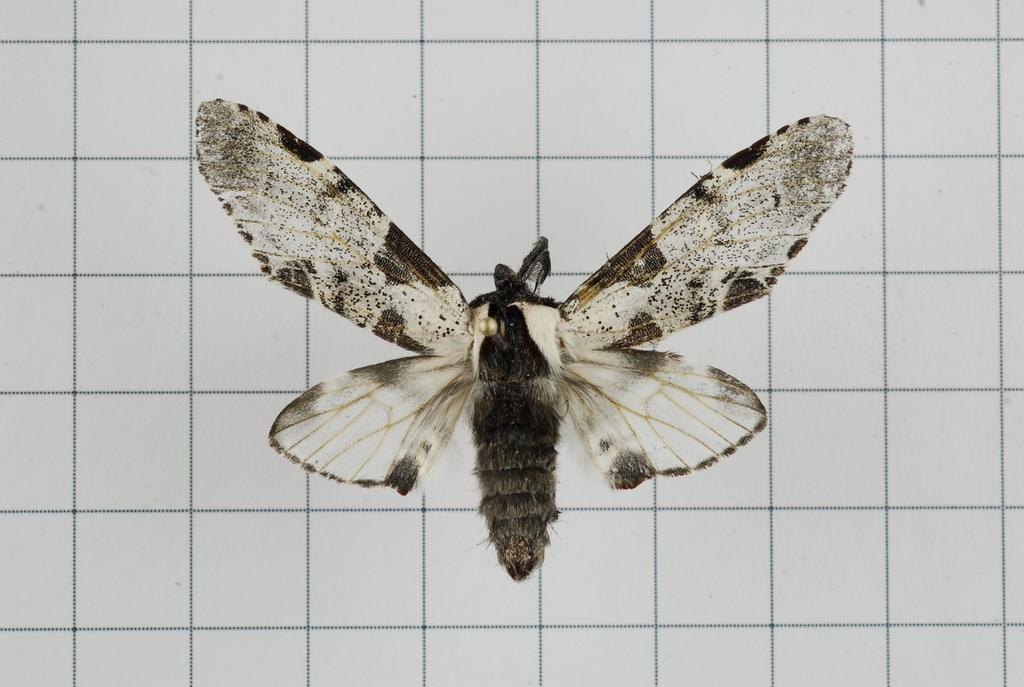What is the main subject of the picture? The main subject of the picture is a butterfly. What can be seen in the background of the picture? The background of the picture appears to have tiles. What type of horn is visible on the butterfly in the image? There is no horn present on the butterfly in the image. How many additional butterflies can be seen in the image? The provided facts do not mention any other butterflies in the image, so we cannot determine the number. 